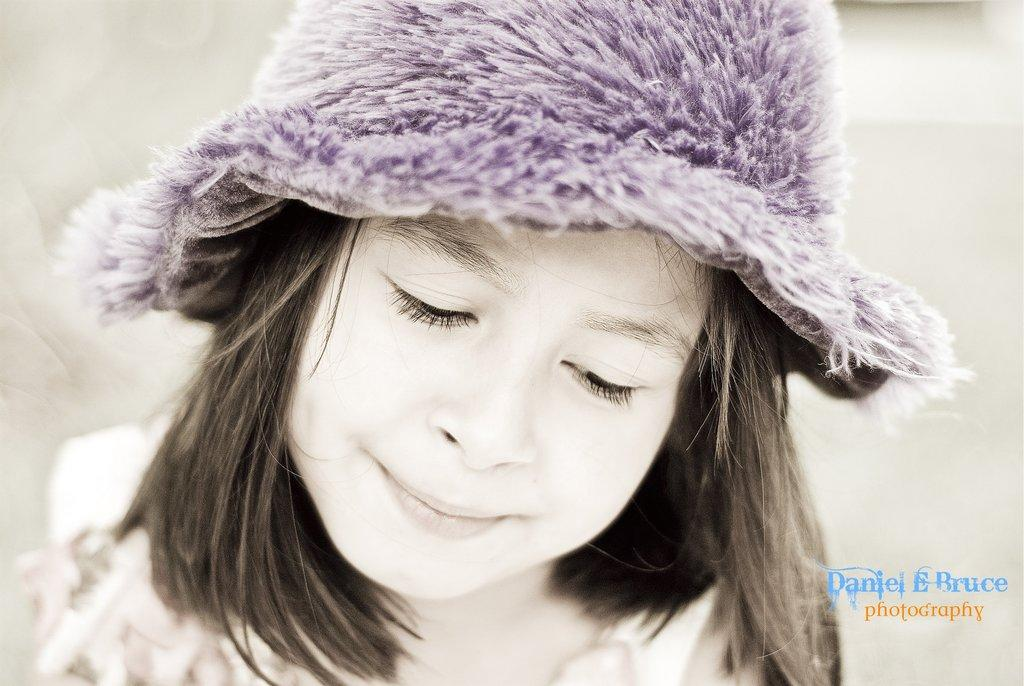Who is the main subject in the image? There is a girl in the image. What is the girl wearing on her head? The girl is wearing a violet color cap. Can you describe the girl's hair? The girl has short hair. Is there any text present in the image? Yes, there is text written on the image. What type of beast can be seen interacting with the girl in the image? There is no beast present in the image; it only features the girl wearing a violet color cap and having short hair, along with text written on it. 